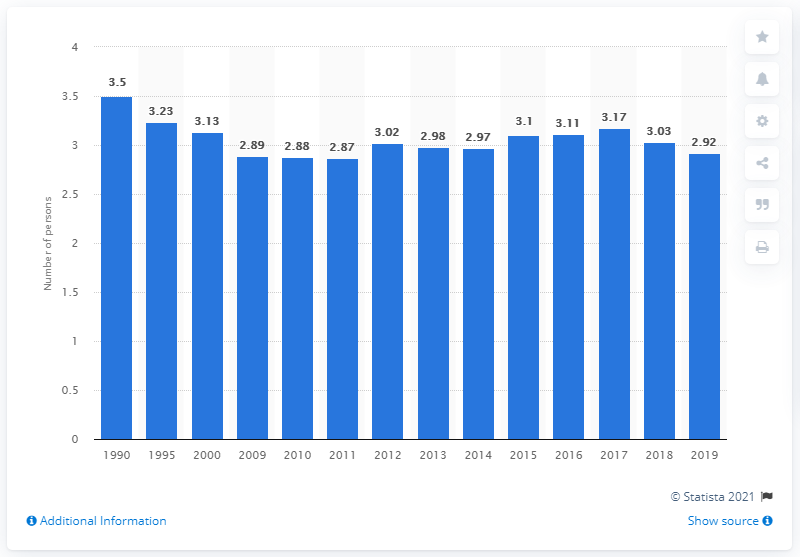Indicate a few pertinent items in this graphic. According to data from 1990 to 2019, an average Chinese household typically contained 2.92 people. 